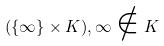<formula> <loc_0><loc_0><loc_500><loc_500>( \{ \infty \} \times K ) , \infty \notin K</formula> 